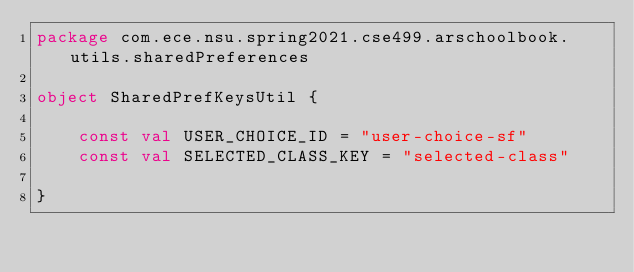Convert code to text. <code><loc_0><loc_0><loc_500><loc_500><_Kotlin_>package com.ece.nsu.spring2021.cse499.arschoolbook.utils.sharedPreferences

object SharedPrefKeysUtil {

    const val USER_CHOICE_ID = "user-choice-sf"
    const val SELECTED_CLASS_KEY = "selected-class"

}</code> 